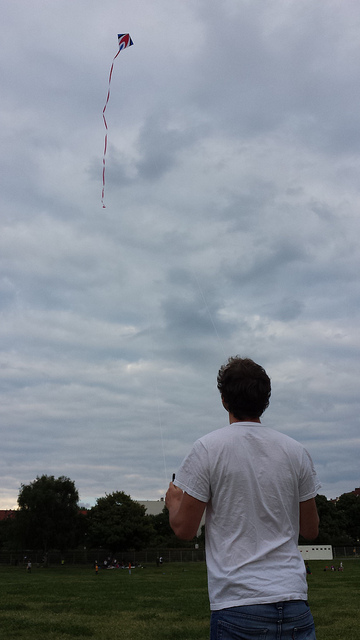<image>In what city is this man flying his kite? I'm not sure about the city this man is flying his kite in. The city could be Cleveland, Baltimore, New York, Los Angeles, San Francisco, or Topeka. In what city is this man flying his kite? I don't know in what city the man is flying his kite. It can be Cleveland, Baltimore, New York, Los Angeles, San Francisco, or Topeka. 